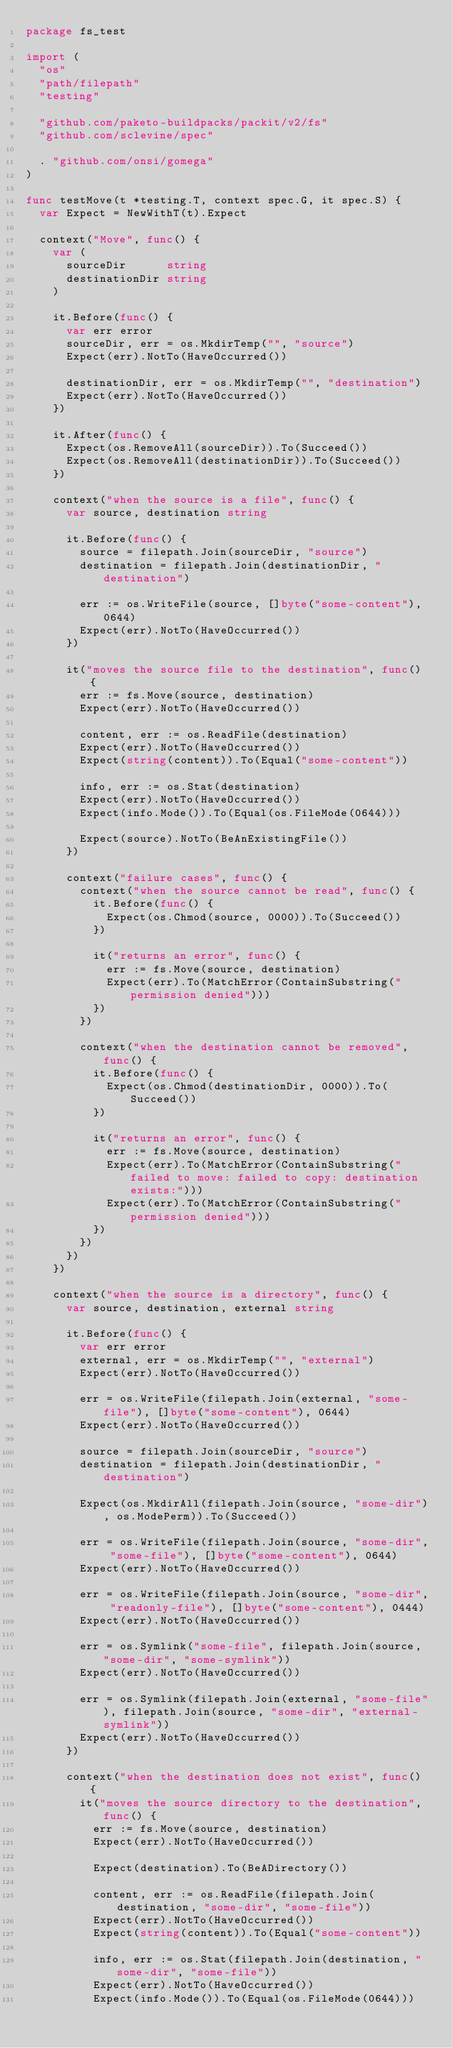Convert code to text. <code><loc_0><loc_0><loc_500><loc_500><_Go_>package fs_test

import (
	"os"
	"path/filepath"
	"testing"

	"github.com/paketo-buildpacks/packit/v2/fs"
	"github.com/sclevine/spec"

	. "github.com/onsi/gomega"
)

func testMove(t *testing.T, context spec.G, it spec.S) {
	var Expect = NewWithT(t).Expect

	context("Move", func() {
		var (
			sourceDir      string
			destinationDir string
		)

		it.Before(func() {
			var err error
			sourceDir, err = os.MkdirTemp("", "source")
			Expect(err).NotTo(HaveOccurred())

			destinationDir, err = os.MkdirTemp("", "destination")
			Expect(err).NotTo(HaveOccurred())
		})

		it.After(func() {
			Expect(os.RemoveAll(sourceDir)).To(Succeed())
			Expect(os.RemoveAll(destinationDir)).To(Succeed())
		})

		context("when the source is a file", func() {
			var source, destination string

			it.Before(func() {
				source = filepath.Join(sourceDir, "source")
				destination = filepath.Join(destinationDir, "destination")

				err := os.WriteFile(source, []byte("some-content"), 0644)
				Expect(err).NotTo(HaveOccurred())
			})

			it("moves the source file to the destination", func() {
				err := fs.Move(source, destination)
				Expect(err).NotTo(HaveOccurred())

				content, err := os.ReadFile(destination)
				Expect(err).NotTo(HaveOccurred())
				Expect(string(content)).To(Equal("some-content"))

				info, err := os.Stat(destination)
				Expect(err).NotTo(HaveOccurred())
				Expect(info.Mode()).To(Equal(os.FileMode(0644)))

				Expect(source).NotTo(BeAnExistingFile())
			})

			context("failure cases", func() {
				context("when the source cannot be read", func() {
					it.Before(func() {
						Expect(os.Chmod(source, 0000)).To(Succeed())
					})

					it("returns an error", func() {
						err := fs.Move(source, destination)
						Expect(err).To(MatchError(ContainSubstring("permission denied")))
					})
				})

				context("when the destination cannot be removed", func() {
					it.Before(func() {
						Expect(os.Chmod(destinationDir, 0000)).To(Succeed())
					})

					it("returns an error", func() {
						err := fs.Move(source, destination)
						Expect(err).To(MatchError(ContainSubstring("failed to move: failed to copy: destination exists:")))
						Expect(err).To(MatchError(ContainSubstring("permission denied")))
					})
				})
			})
		})

		context("when the source is a directory", func() {
			var source, destination, external string

			it.Before(func() {
				var err error
				external, err = os.MkdirTemp("", "external")
				Expect(err).NotTo(HaveOccurred())

				err = os.WriteFile(filepath.Join(external, "some-file"), []byte("some-content"), 0644)
				Expect(err).NotTo(HaveOccurred())

				source = filepath.Join(sourceDir, "source")
				destination = filepath.Join(destinationDir, "destination")

				Expect(os.MkdirAll(filepath.Join(source, "some-dir"), os.ModePerm)).To(Succeed())

				err = os.WriteFile(filepath.Join(source, "some-dir", "some-file"), []byte("some-content"), 0644)
				Expect(err).NotTo(HaveOccurred())

				err = os.WriteFile(filepath.Join(source, "some-dir", "readonly-file"), []byte("some-content"), 0444)
				Expect(err).NotTo(HaveOccurred())

				err = os.Symlink("some-file", filepath.Join(source, "some-dir", "some-symlink"))
				Expect(err).NotTo(HaveOccurred())

				err = os.Symlink(filepath.Join(external, "some-file"), filepath.Join(source, "some-dir", "external-symlink"))
				Expect(err).NotTo(HaveOccurred())
			})

			context("when the destination does not exist", func() {
				it("moves the source directory to the destination", func() {
					err := fs.Move(source, destination)
					Expect(err).NotTo(HaveOccurred())

					Expect(destination).To(BeADirectory())

					content, err := os.ReadFile(filepath.Join(destination, "some-dir", "some-file"))
					Expect(err).NotTo(HaveOccurred())
					Expect(string(content)).To(Equal("some-content"))

					info, err := os.Stat(filepath.Join(destination, "some-dir", "some-file"))
					Expect(err).NotTo(HaveOccurred())
					Expect(info.Mode()).To(Equal(os.FileMode(0644)))
</code> 